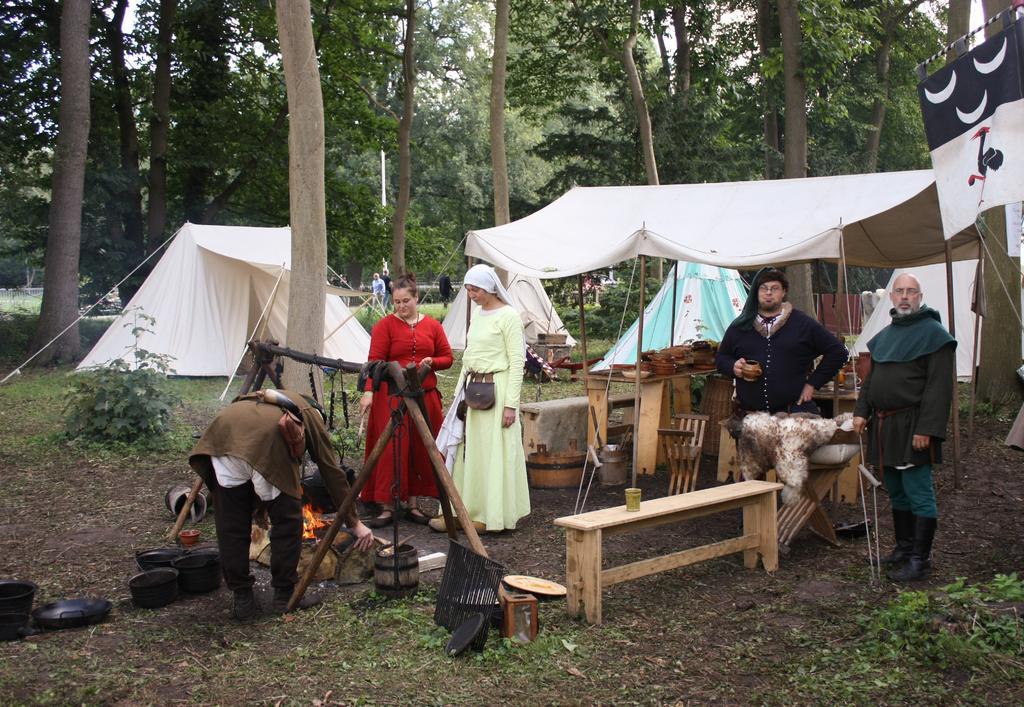In one or two sentences, can you explain what this image depicts? In this picture there are people and we can see objects on tables, glass on the bench, wooden stand, bowls, pan, bucket and objects. We can see grass, tents, banner, plants and trees. In the background of the image we can see the sky. 